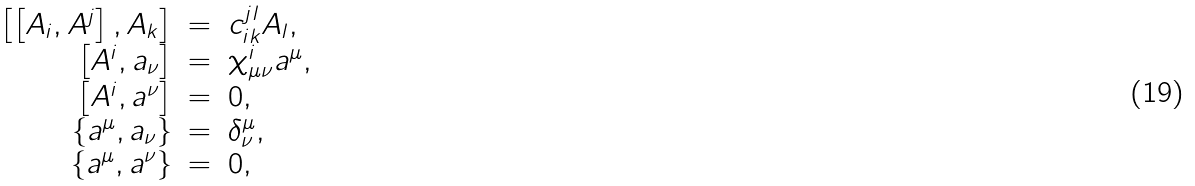Convert formula to latex. <formula><loc_0><loc_0><loc_500><loc_500>\begin{array} { r c l } \left [ \left [ A _ { i } , A ^ { j } \right ] , A _ { k } \right ] & = & c ^ { j l } _ { i k } A _ { l } , \\ \left [ A ^ { i } , a _ { \nu } \right ] & = & \chi ^ { i } _ { \mu \nu } a ^ { \mu } , \\ \left [ A ^ { i } , a ^ { \nu } \right ] & = & 0 , \\ \left \{ a ^ { \mu } , a _ { \nu } \right \} & = & \delta ^ { \mu } _ { \nu } , \\ \left \{ a ^ { \mu } , a ^ { \nu } \right \} & = & 0 , \\ \end{array}</formula> 